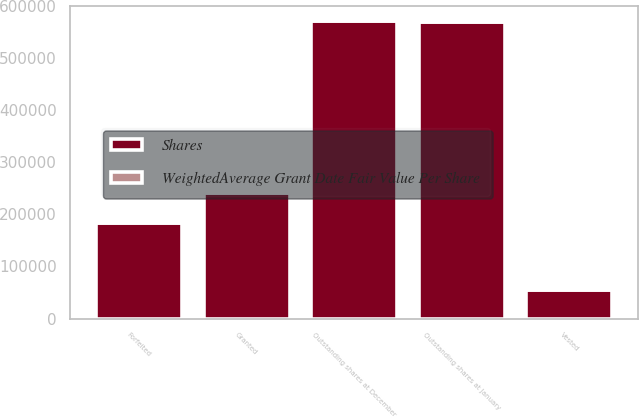Convert chart to OTSL. <chart><loc_0><loc_0><loc_500><loc_500><stacked_bar_chart><ecel><fcel>Outstanding shares at January<fcel>Granted<fcel>Vested<fcel>Forfeited<fcel>Outstanding shares at December<nl><fcel>Shares<fcel>568482<fcel>241236<fcel>54103<fcel>184064<fcel>571551<nl><fcel>WeightedAverage Grant Date Fair Value Per Share<fcel>75.33<fcel>85.26<fcel>65.36<fcel>70.53<fcel>82.02<nl></chart> 